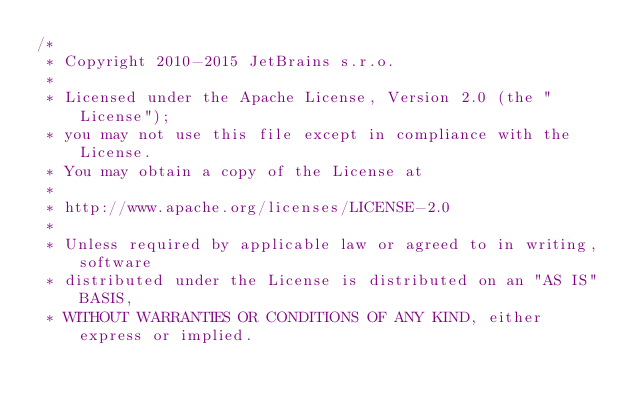<code> <loc_0><loc_0><loc_500><loc_500><_Kotlin_>/*
 * Copyright 2010-2015 JetBrains s.r.o.
 *
 * Licensed under the Apache License, Version 2.0 (the "License");
 * you may not use this file except in compliance with the License.
 * You may obtain a copy of the License at
 *
 * http://www.apache.org/licenses/LICENSE-2.0
 *
 * Unless required by applicable law or agreed to in writing, software
 * distributed under the License is distributed on an "AS IS" BASIS,
 * WITHOUT WARRANTIES OR CONDITIONS OF ANY KIND, either express or implied.</code> 